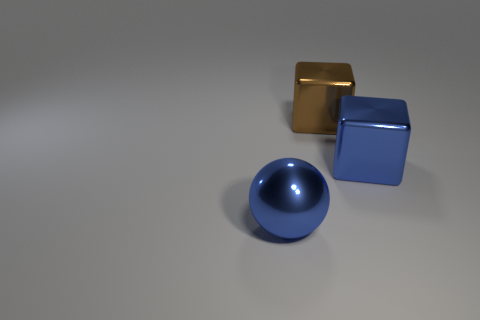What is the color of the object that is in front of the large brown object and to the left of the large blue metal block?
Your response must be concise. Blue. How many spheres are either brown metallic objects or blue shiny objects?
Your response must be concise. 1. Is the number of large blue balls behind the brown thing less than the number of large objects?
Provide a short and direct response. Yes. There is a brown object that is made of the same material as the blue cube; what shape is it?
Give a very brief answer. Cube. How many metallic objects are the same color as the ball?
Your answer should be compact. 1. How many things are big blue things or brown blocks?
Your answer should be compact. 3. There is a brown object left of the big blue object that is behind the blue shiny ball; what is it made of?
Keep it short and to the point. Metal. Are there any other big blue cubes that have the same material as the blue block?
Ensure brevity in your answer.  No. There is a large metal object in front of the blue shiny thing that is behind the metal thing on the left side of the big brown shiny object; what is its shape?
Give a very brief answer. Sphere. What material is the big blue sphere?
Your response must be concise. Metal. 